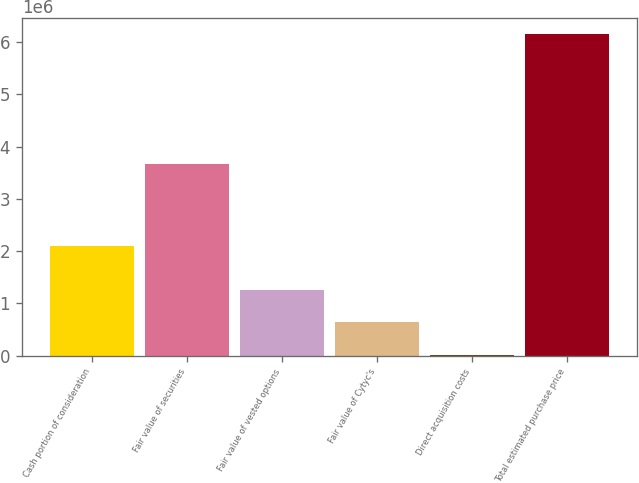<chart> <loc_0><loc_0><loc_500><loc_500><bar_chart><fcel>Cash portion of consideration<fcel>Fair value of securities<fcel>Fair value of vested options<fcel>Fair value of Cytyc's<fcel>Direct acquisition costs<fcel>Total estimated purchase price<nl><fcel>2.0948e+06<fcel>3.6715e+06<fcel>1.25074e+06<fcel>637470<fcel>24200<fcel>6.1569e+06<nl></chart> 